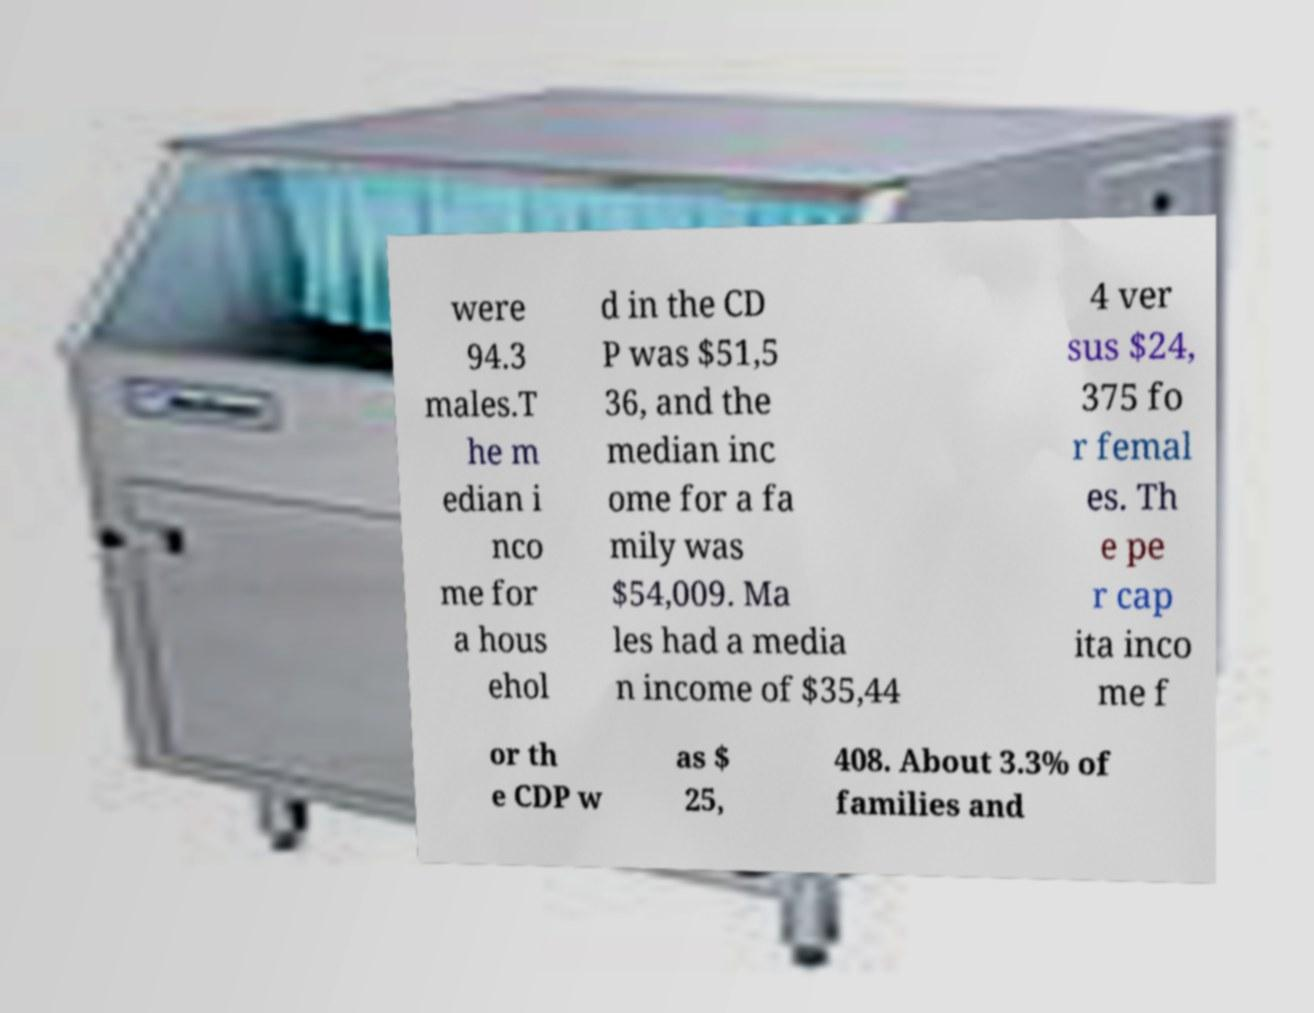Please read and relay the text visible in this image. What does it say? were 94.3 males.T he m edian i nco me for a hous ehol d in the CD P was $51,5 36, and the median inc ome for a fa mily was $54,009. Ma les had a media n income of $35,44 4 ver sus $24, 375 fo r femal es. Th e pe r cap ita inco me f or th e CDP w as $ 25, 408. About 3.3% of families and 